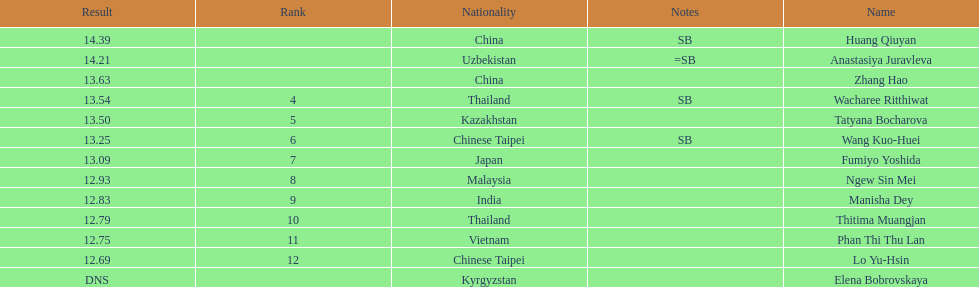What nationality was the woman who won first place? China. 